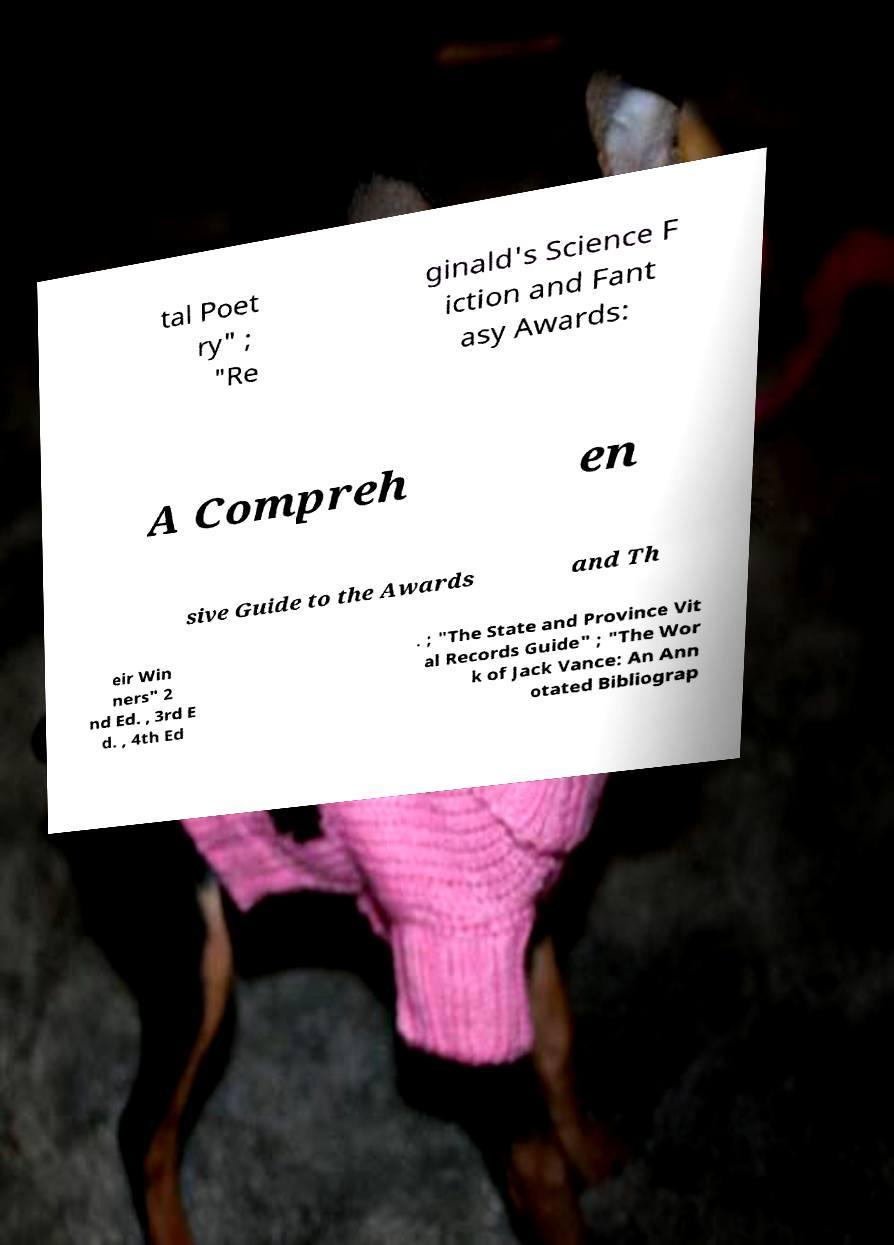Could you assist in decoding the text presented in this image and type it out clearly? tal Poet ry" ; "Re ginald's Science F iction and Fant asy Awards: A Compreh en sive Guide to the Awards and Th eir Win ners" 2 nd Ed. , 3rd E d. , 4th Ed . ; "The State and Province Vit al Records Guide" ; "The Wor k of Jack Vance: An Ann otated Bibliograp 